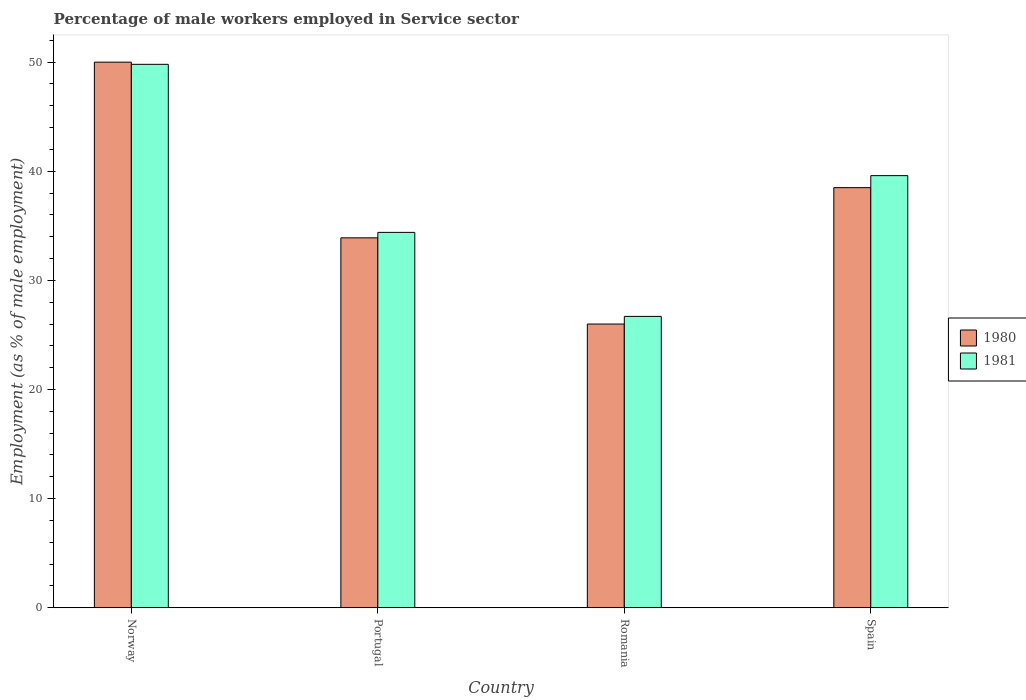How many different coloured bars are there?
Provide a succinct answer. 2. How many groups of bars are there?
Make the answer very short. 4. What is the label of the 4th group of bars from the left?
Your answer should be compact. Spain. In how many cases, is the number of bars for a given country not equal to the number of legend labels?
Offer a very short reply. 0. What is the percentage of male workers employed in Service sector in 1980 in Spain?
Provide a short and direct response. 38.5. Across all countries, what is the maximum percentage of male workers employed in Service sector in 1981?
Your response must be concise. 49.8. Across all countries, what is the minimum percentage of male workers employed in Service sector in 1980?
Make the answer very short. 26. In which country was the percentage of male workers employed in Service sector in 1980 maximum?
Make the answer very short. Norway. In which country was the percentage of male workers employed in Service sector in 1980 minimum?
Your response must be concise. Romania. What is the total percentage of male workers employed in Service sector in 1981 in the graph?
Your response must be concise. 150.5. What is the difference between the percentage of male workers employed in Service sector in 1981 in Portugal and the percentage of male workers employed in Service sector in 1980 in Spain?
Provide a succinct answer. -4.1. What is the average percentage of male workers employed in Service sector in 1981 per country?
Offer a very short reply. 37.62. What is the difference between the percentage of male workers employed in Service sector of/in 1981 and percentage of male workers employed in Service sector of/in 1980 in Norway?
Provide a short and direct response. -0.2. What is the ratio of the percentage of male workers employed in Service sector in 1980 in Norway to that in Spain?
Keep it short and to the point. 1.3. Is the percentage of male workers employed in Service sector in 1980 in Norway less than that in Romania?
Offer a very short reply. No. Is the difference between the percentage of male workers employed in Service sector in 1981 in Norway and Romania greater than the difference between the percentage of male workers employed in Service sector in 1980 in Norway and Romania?
Provide a short and direct response. No. What is the difference between the highest and the second highest percentage of male workers employed in Service sector in 1981?
Your answer should be compact. 15.4. Is the sum of the percentage of male workers employed in Service sector in 1981 in Portugal and Spain greater than the maximum percentage of male workers employed in Service sector in 1980 across all countries?
Offer a very short reply. Yes. How many bars are there?
Your response must be concise. 8. Are all the bars in the graph horizontal?
Keep it short and to the point. No. How many countries are there in the graph?
Give a very brief answer. 4. Are the values on the major ticks of Y-axis written in scientific E-notation?
Ensure brevity in your answer.  No. Does the graph contain grids?
Ensure brevity in your answer.  No. Where does the legend appear in the graph?
Ensure brevity in your answer.  Center right. How are the legend labels stacked?
Ensure brevity in your answer.  Vertical. What is the title of the graph?
Keep it short and to the point. Percentage of male workers employed in Service sector. Does "1978" appear as one of the legend labels in the graph?
Your answer should be compact. No. What is the label or title of the X-axis?
Your response must be concise. Country. What is the label or title of the Y-axis?
Your answer should be very brief. Employment (as % of male employment). What is the Employment (as % of male employment) of 1980 in Norway?
Your response must be concise. 50. What is the Employment (as % of male employment) of 1981 in Norway?
Provide a short and direct response. 49.8. What is the Employment (as % of male employment) in 1980 in Portugal?
Provide a succinct answer. 33.9. What is the Employment (as % of male employment) of 1981 in Portugal?
Give a very brief answer. 34.4. What is the Employment (as % of male employment) of 1980 in Romania?
Offer a very short reply. 26. What is the Employment (as % of male employment) in 1981 in Romania?
Provide a short and direct response. 26.7. What is the Employment (as % of male employment) in 1980 in Spain?
Keep it short and to the point. 38.5. What is the Employment (as % of male employment) in 1981 in Spain?
Offer a very short reply. 39.6. Across all countries, what is the maximum Employment (as % of male employment) in 1981?
Keep it short and to the point. 49.8. Across all countries, what is the minimum Employment (as % of male employment) in 1980?
Provide a short and direct response. 26. Across all countries, what is the minimum Employment (as % of male employment) of 1981?
Your answer should be compact. 26.7. What is the total Employment (as % of male employment) in 1980 in the graph?
Your answer should be very brief. 148.4. What is the total Employment (as % of male employment) in 1981 in the graph?
Offer a very short reply. 150.5. What is the difference between the Employment (as % of male employment) of 1980 in Norway and that in Romania?
Offer a very short reply. 24. What is the difference between the Employment (as % of male employment) in 1981 in Norway and that in Romania?
Give a very brief answer. 23.1. What is the difference between the Employment (as % of male employment) in 1980 in Norway and the Employment (as % of male employment) in 1981 in Portugal?
Provide a short and direct response. 15.6. What is the difference between the Employment (as % of male employment) of 1980 in Norway and the Employment (as % of male employment) of 1981 in Romania?
Keep it short and to the point. 23.3. What is the difference between the Employment (as % of male employment) of 1980 in Norway and the Employment (as % of male employment) of 1981 in Spain?
Offer a very short reply. 10.4. What is the difference between the Employment (as % of male employment) of 1980 in Portugal and the Employment (as % of male employment) of 1981 in Romania?
Ensure brevity in your answer.  7.2. What is the average Employment (as % of male employment) of 1980 per country?
Keep it short and to the point. 37.1. What is the average Employment (as % of male employment) in 1981 per country?
Offer a terse response. 37.62. What is the difference between the Employment (as % of male employment) of 1980 and Employment (as % of male employment) of 1981 in Norway?
Make the answer very short. 0.2. What is the difference between the Employment (as % of male employment) in 1980 and Employment (as % of male employment) in 1981 in Romania?
Offer a terse response. -0.7. What is the difference between the Employment (as % of male employment) of 1980 and Employment (as % of male employment) of 1981 in Spain?
Offer a very short reply. -1.1. What is the ratio of the Employment (as % of male employment) in 1980 in Norway to that in Portugal?
Make the answer very short. 1.47. What is the ratio of the Employment (as % of male employment) in 1981 in Norway to that in Portugal?
Make the answer very short. 1.45. What is the ratio of the Employment (as % of male employment) of 1980 in Norway to that in Romania?
Offer a very short reply. 1.92. What is the ratio of the Employment (as % of male employment) of 1981 in Norway to that in Romania?
Your response must be concise. 1.87. What is the ratio of the Employment (as % of male employment) of 1980 in Norway to that in Spain?
Give a very brief answer. 1.3. What is the ratio of the Employment (as % of male employment) in 1981 in Norway to that in Spain?
Your answer should be compact. 1.26. What is the ratio of the Employment (as % of male employment) of 1980 in Portugal to that in Romania?
Your answer should be very brief. 1.3. What is the ratio of the Employment (as % of male employment) in 1981 in Portugal to that in Romania?
Offer a terse response. 1.29. What is the ratio of the Employment (as % of male employment) of 1980 in Portugal to that in Spain?
Offer a very short reply. 0.88. What is the ratio of the Employment (as % of male employment) in 1981 in Portugal to that in Spain?
Give a very brief answer. 0.87. What is the ratio of the Employment (as % of male employment) in 1980 in Romania to that in Spain?
Give a very brief answer. 0.68. What is the ratio of the Employment (as % of male employment) of 1981 in Romania to that in Spain?
Your answer should be compact. 0.67. What is the difference between the highest and the second highest Employment (as % of male employment) in 1980?
Offer a terse response. 11.5. What is the difference between the highest and the second highest Employment (as % of male employment) in 1981?
Your answer should be compact. 10.2. What is the difference between the highest and the lowest Employment (as % of male employment) in 1980?
Offer a very short reply. 24. What is the difference between the highest and the lowest Employment (as % of male employment) in 1981?
Provide a succinct answer. 23.1. 